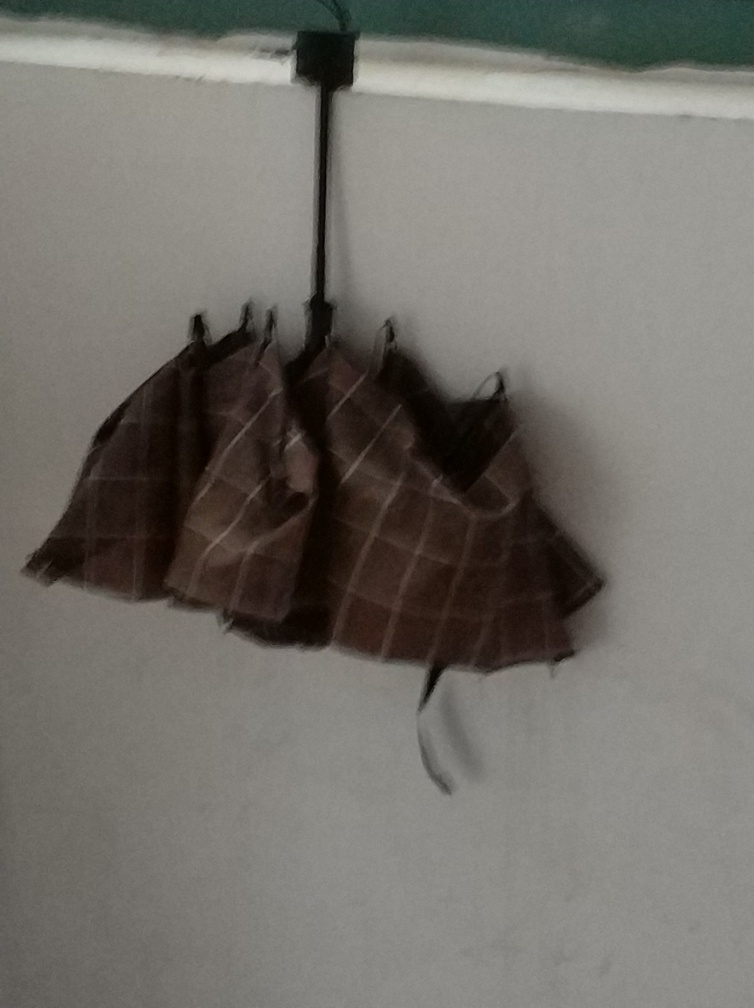What mood or atmosphere does the image convey to you? The image has a somewhat muted and bland atmosphere due to the lack of vibrant colors and minimalistic content. The blurred focus lends a sense of impermanence or fleetingness to the scene. Can you guess at what time of day this photo might have been taken? Without visible windows or natural light sources, it's hard to determine the time of day with precision. The artificial light source at the top may imply indoor lighting, which is commonly used throughout the day, so the timing remains ambiguous. 